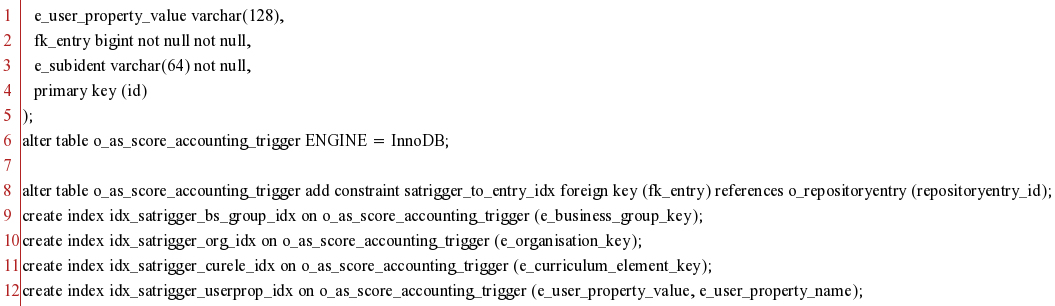<code> <loc_0><loc_0><loc_500><loc_500><_SQL_>   e_user_property_value varchar(128),
   fk_entry bigint not null not null,
   e_subident varchar(64) not null,
   primary key (id)
);
alter table o_as_score_accounting_trigger ENGINE = InnoDB;

alter table o_as_score_accounting_trigger add constraint satrigger_to_entry_idx foreign key (fk_entry) references o_repositoryentry (repositoryentry_id);
create index idx_satrigger_bs_group_idx on o_as_score_accounting_trigger (e_business_group_key);
create index idx_satrigger_org_idx on o_as_score_accounting_trigger (e_organisation_key);
create index idx_satrigger_curele_idx on o_as_score_accounting_trigger (e_curriculum_element_key);
create index idx_satrigger_userprop_idx on o_as_score_accounting_trigger (e_user_property_value, e_user_property_name);
</code> 